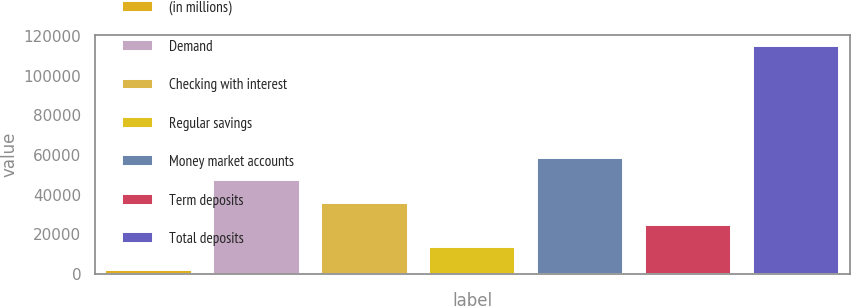<chart> <loc_0><loc_0><loc_500><loc_500><bar_chart><fcel>(in millions)<fcel>Demand<fcel>Checking with interest<fcel>Regular savings<fcel>Money market accounts<fcel>Term deposits<fcel>Total deposits<nl><fcel>2017<fcel>47245.8<fcel>35938.6<fcel>13324.2<fcel>58553<fcel>24631.4<fcel>115089<nl></chart> 